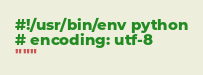Convert code to text. <code><loc_0><loc_0><loc_500><loc_500><_Python_>#!/usr/bin/env python
# encoding: utf-8
"""</code> 